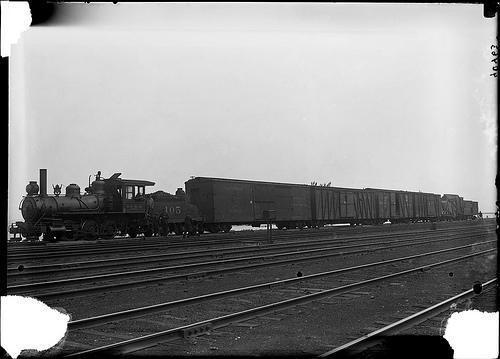How many trains are there?
Give a very brief answer. 1. 